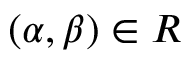Convert formula to latex. <formula><loc_0><loc_0><loc_500><loc_500>( \alpha , \beta ) \in R</formula> 